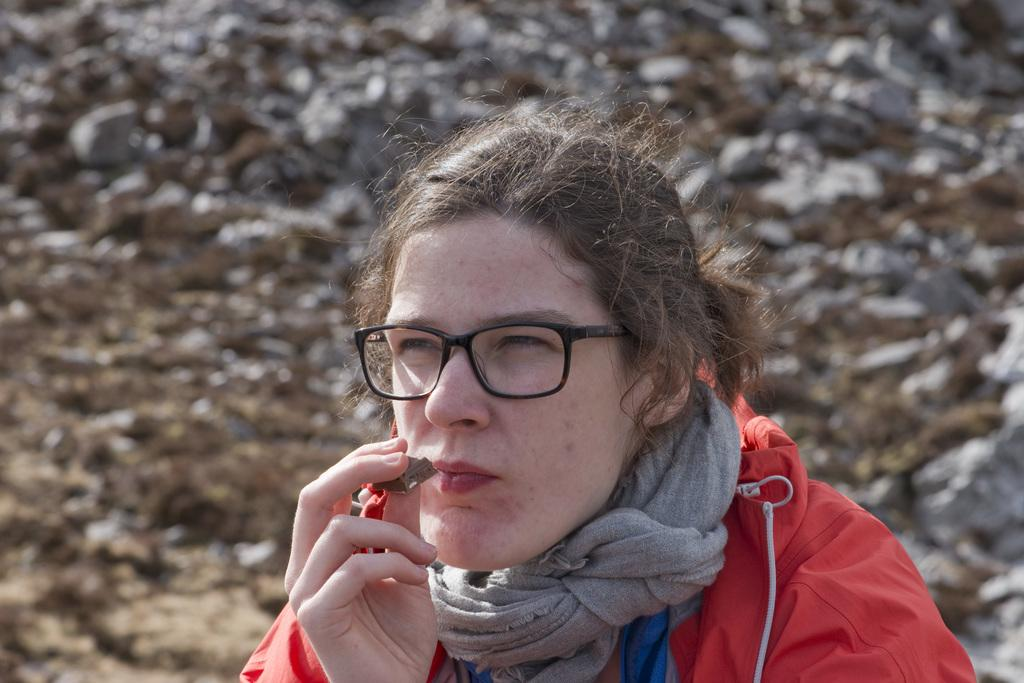Who is the main subject in the image? There is a woman in the image. Where is the woman located in relation to the image? The woman is in the foreground. What is the woman holding in the image? The woman is holding a chocolate. How is the background of the image depicted? The background of the woman is blurred. What type of guitar is the woman playing in the image? There is no guitar present in the image; the woman is holding a chocolate. Can you see a bat flying in the background of the image? There is no bat visible in the image; the background is blurred. 